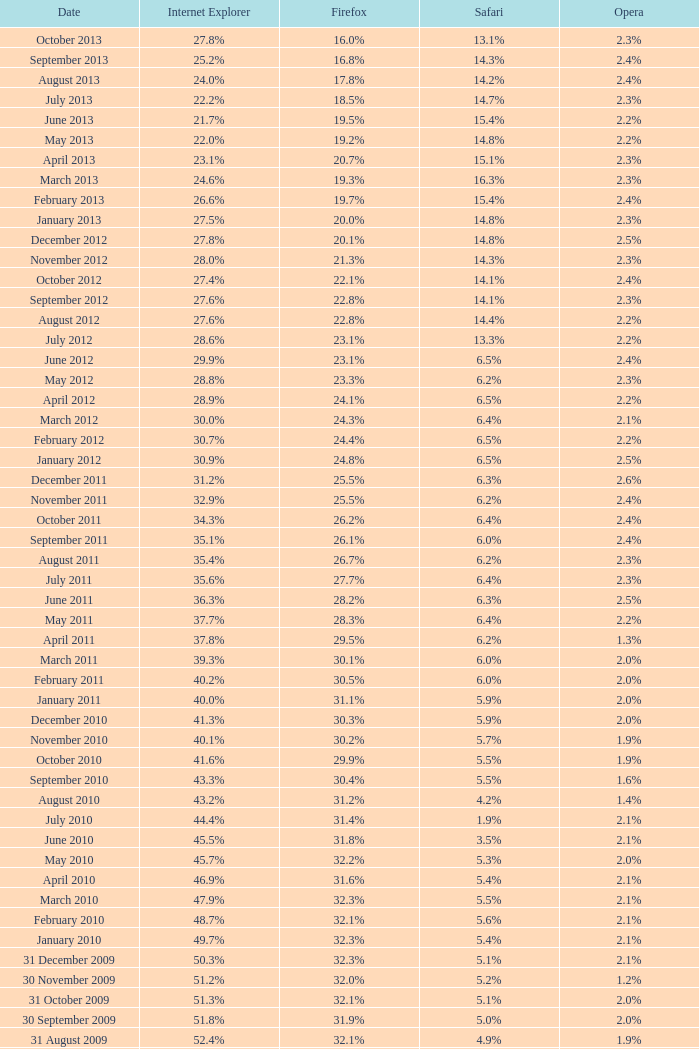8% opera on 30 july 2007? 25.1%. 